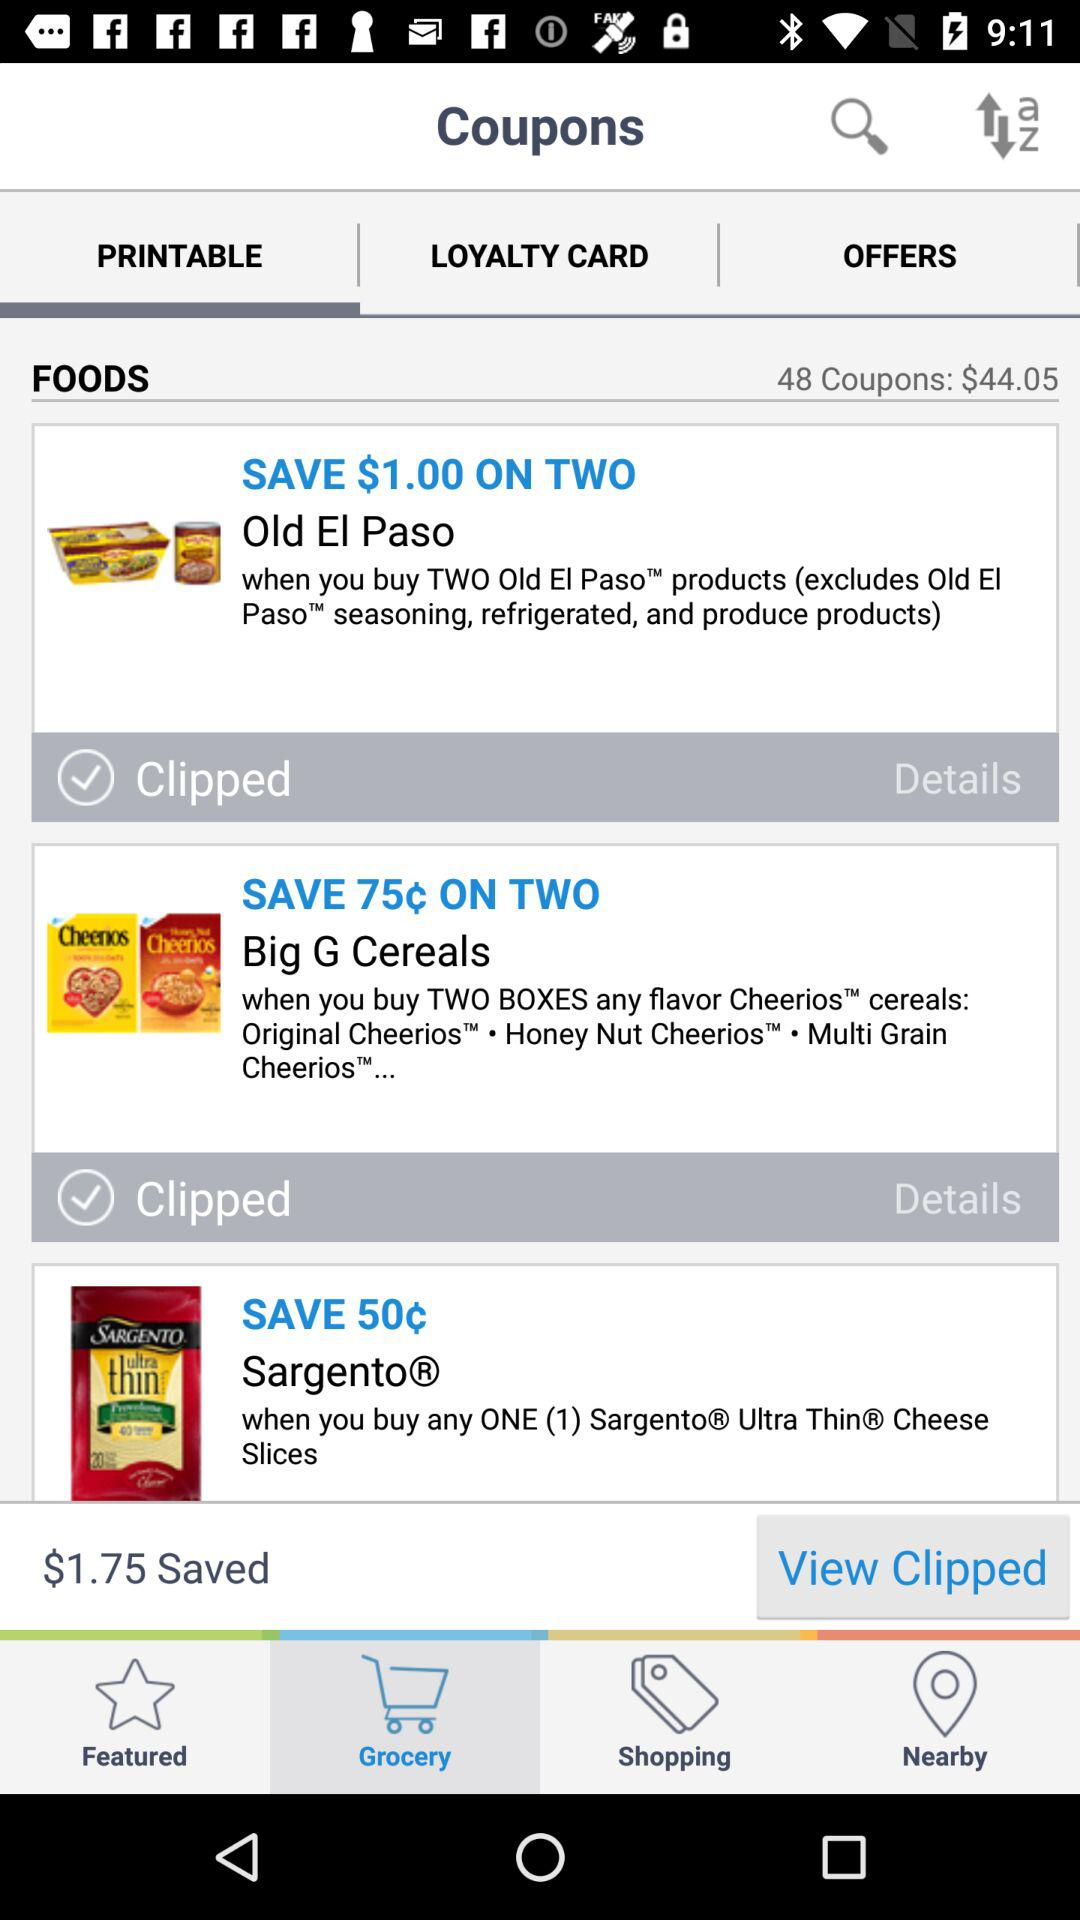How much dollar can we save on the two packs of old El Paso? We can save $1 on the two packs of old El Paso. 